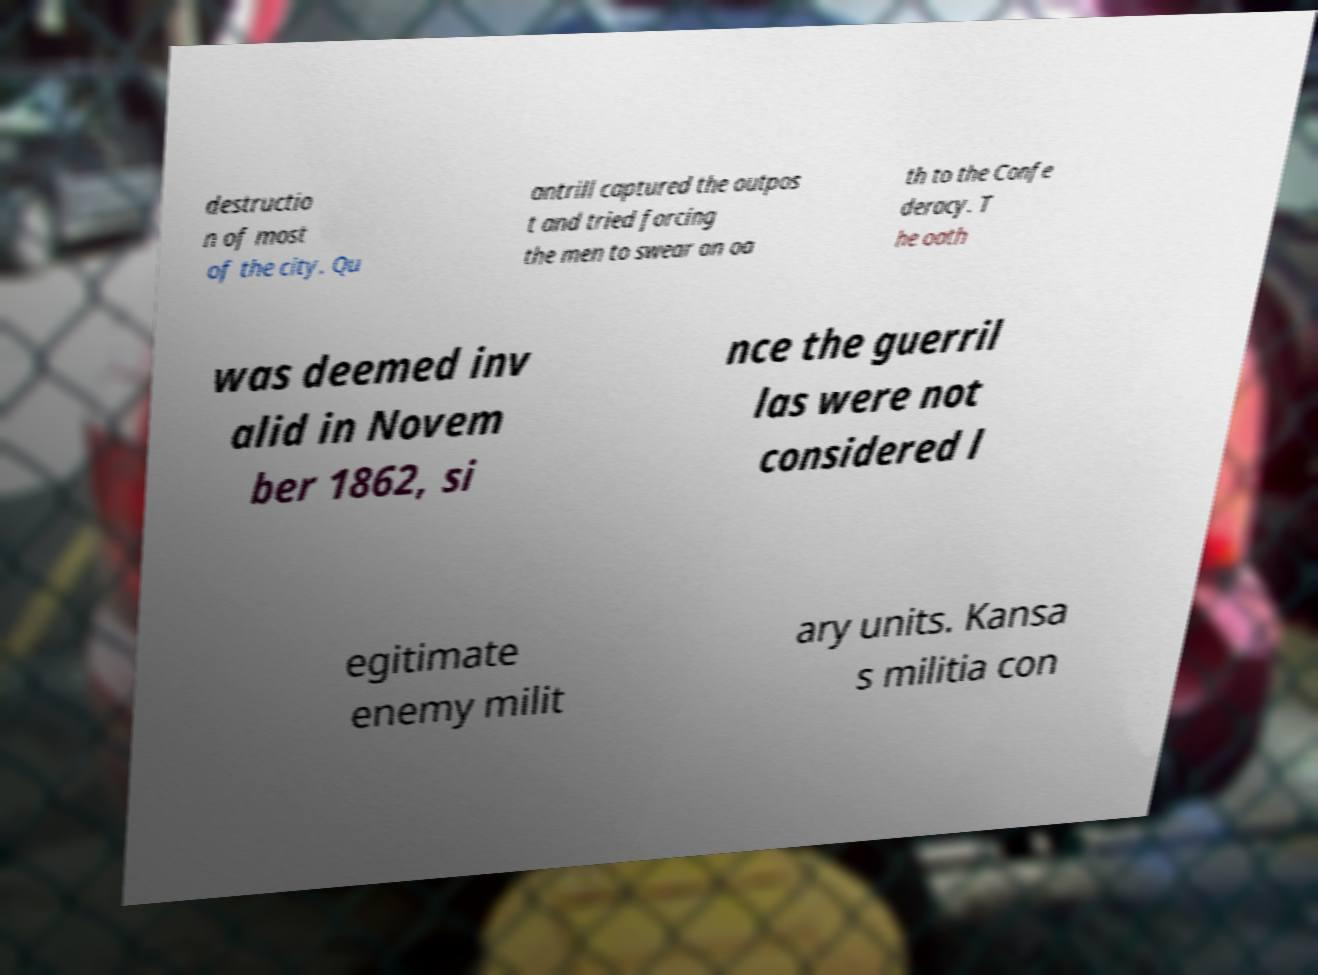I need the written content from this picture converted into text. Can you do that? destructio n of most of the city. Qu antrill captured the outpos t and tried forcing the men to swear an oa th to the Confe deracy. T he oath was deemed inv alid in Novem ber 1862, si nce the guerril las were not considered l egitimate enemy milit ary units. Kansa s militia con 